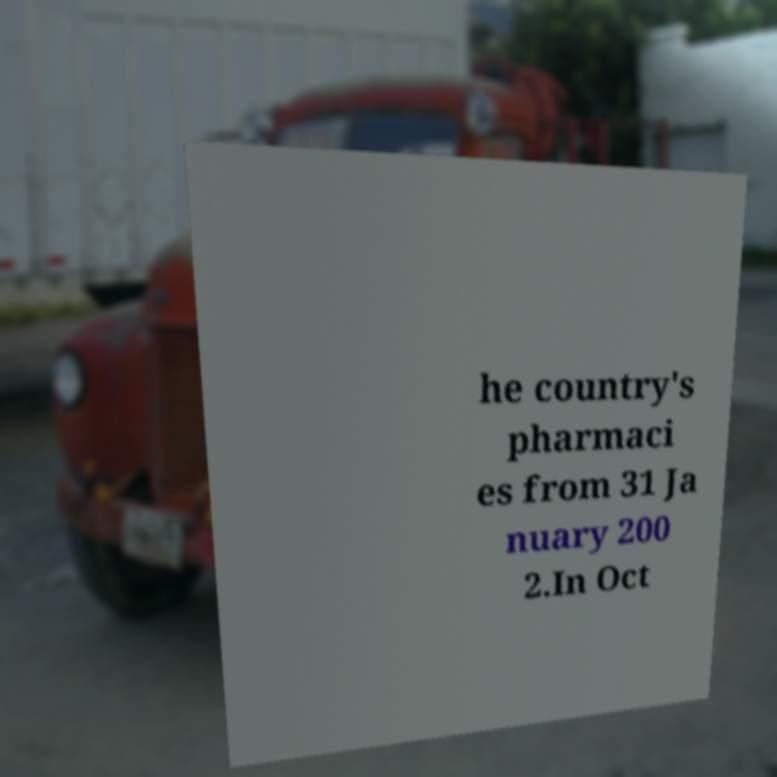Please identify and transcribe the text found in this image. he country's pharmaci es from 31 Ja nuary 200 2.In Oct 